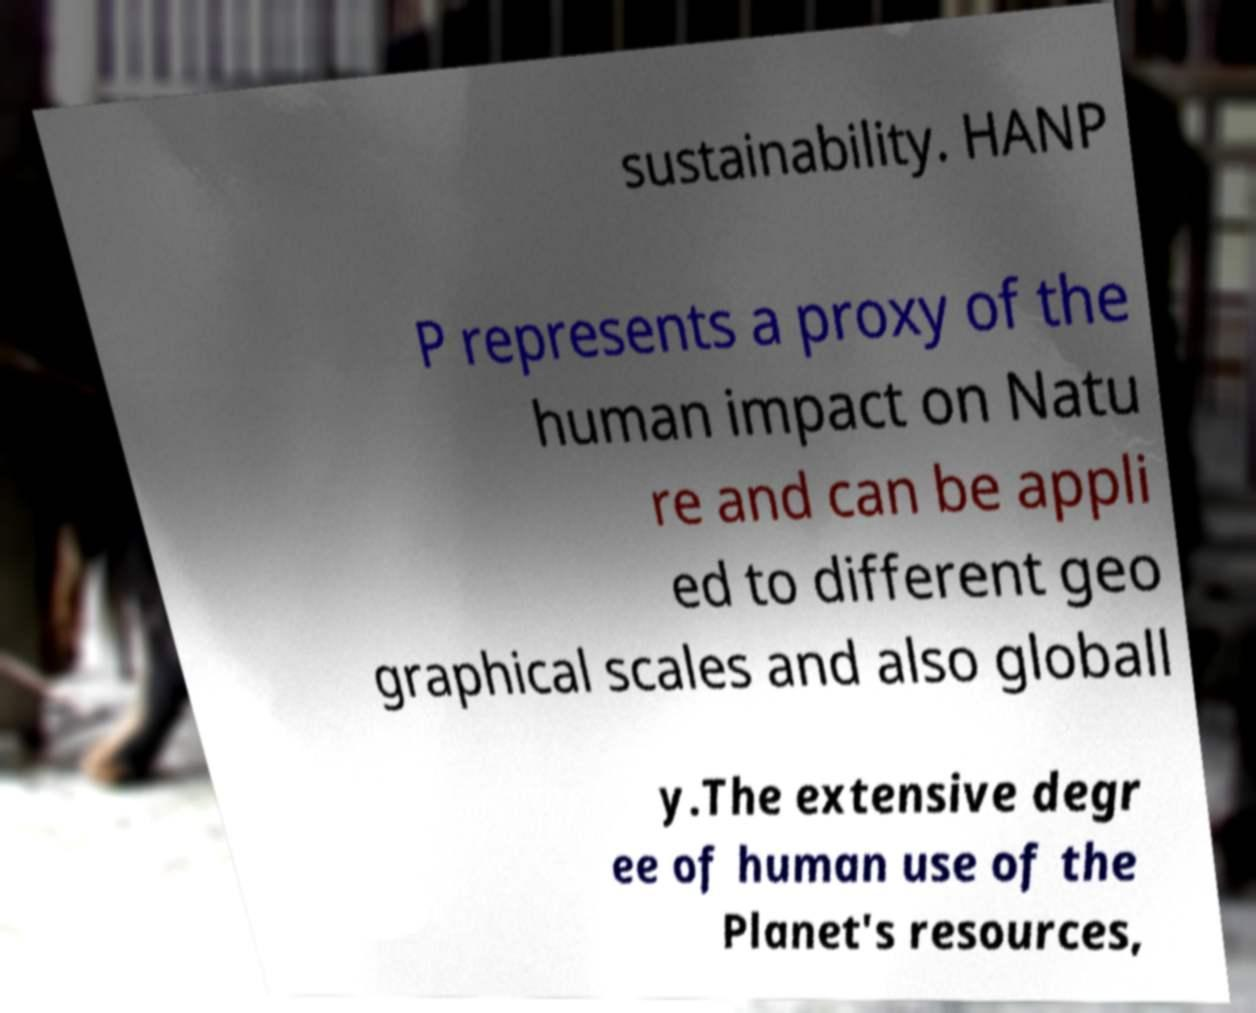Can you accurately transcribe the text from the provided image for me? sustainability. HANP P represents a proxy of the human impact on Natu re and can be appli ed to different geo graphical scales and also globall y.The extensive degr ee of human use of the Planet's resources, 